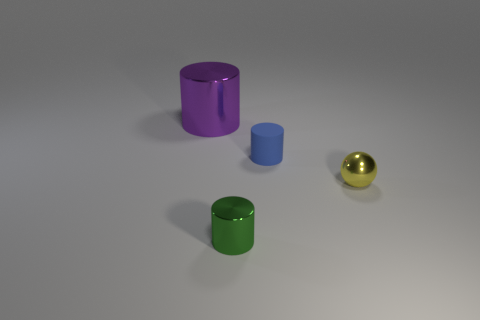There is a yellow thing that is the same size as the rubber cylinder; what is it made of?
Your answer should be very brief. Metal. What number of purple things have the same material as the green cylinder?
Your response must be concise. 1. There is a metal thing that is in front of the tiny metal ball; does it have the same size as the shiny cylinder behind the yellow shiny sphere?
Make the answer very short. No. There is a shiny cylinder that is in front of the purple thing; what color is it?
Ensure brevity in your answer.  Green. What number of shiny things have the same color as the rubber thing?
Ensure brevity in your answer.  0. There is a purple object; is its size the same as the metal cylinder that is in front of the ball?
Make the answer very short. No. There is a shiny thing right of the cylinder that is on the right side of the small cylinder that is left of the small blue cylinder; how big is it?
Your answer should be compact. Small. How many green metallic objects are left of the small green cylinder?
Ensure brevity in your answer.  0. The small cylinder that is behind the shiny cylinder that is in front of the small metal sphere is made of what material?
Provide a succinct answer. Rubber. Is there anything else that is the same size as the purple metallic cylinder?
Your response must be concise. No. 